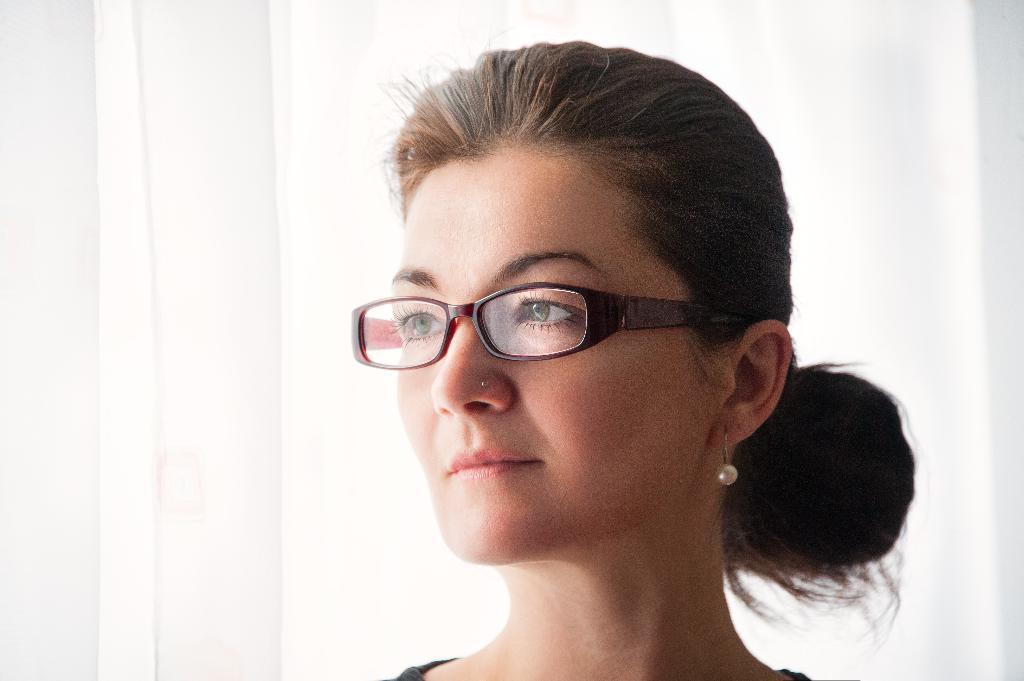Can you describe this image briefly? In this picture we can see a woman wearing spectacles. This is a nose pin. 